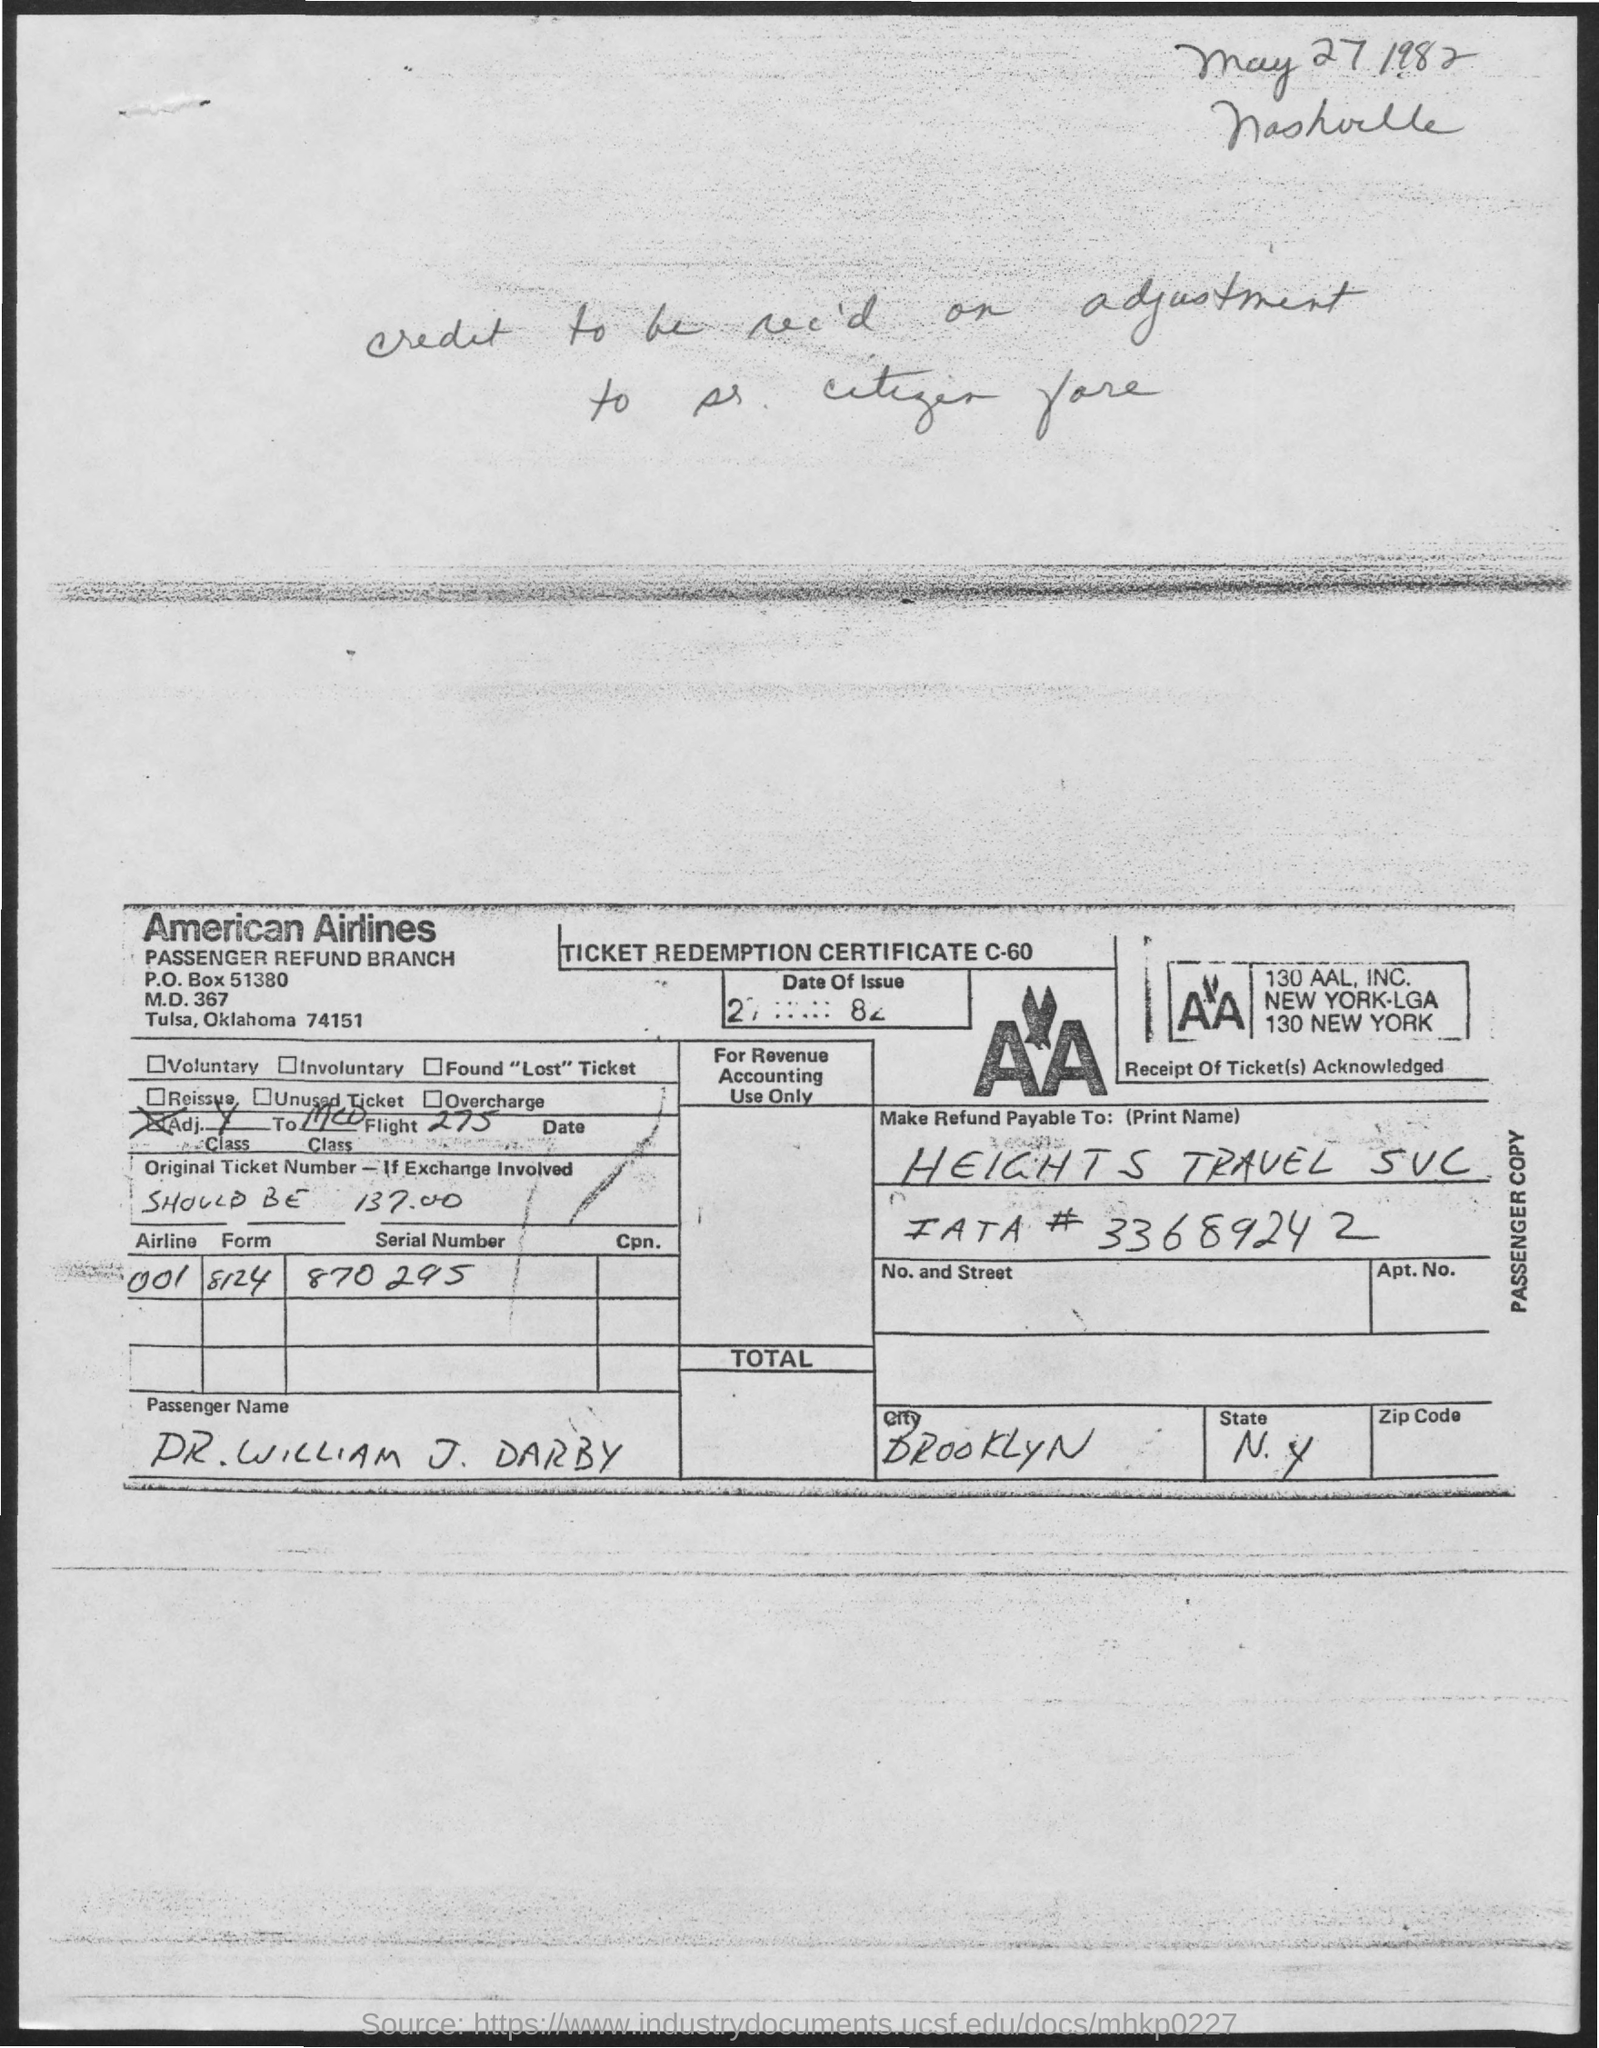What is the name of the Airline?
Give a very brief answer. American airlines. What is the name of the city?
Keep it short and to the point. Brooklyn. What is the name of the state?
Offer a very short reply. N.Y. What is the Airline Code?
Ensure brevity in your answer.  001. What is the form number?
Make the answer very short. 8124. What is the Serial Number?
Your answer should be compact. 870295. What is the PO Box Number mentioned in the document?
Your response must be concise. 51380. 